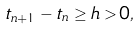Convert formula to latex. <formula><loc_0><loc_0><loc_500><loc_500>t _ { n + 1 } - t _ { n } \geq h > 0 ,</formula> 